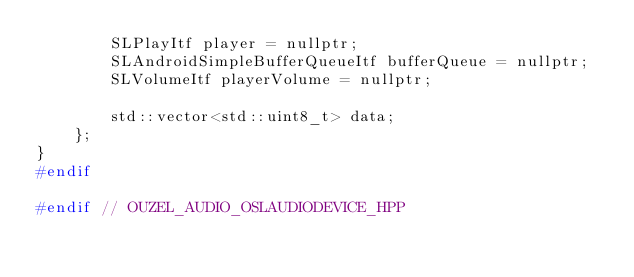<code> <loc_0><loc_0><loc_500><loc_500><_C++_>        SLPlayItf player = nullptr;
        SLAndroidSimpleBufferQueueItf bufferQueue = nullptr;
        SLVolumeItf playerVolume = nullptr;

        std::vector<std::uint8_t> data;
    };
}
#endif

#endif // OUZEL_AUDIO_OSLAUDIODEVICE_HPP
</code> 